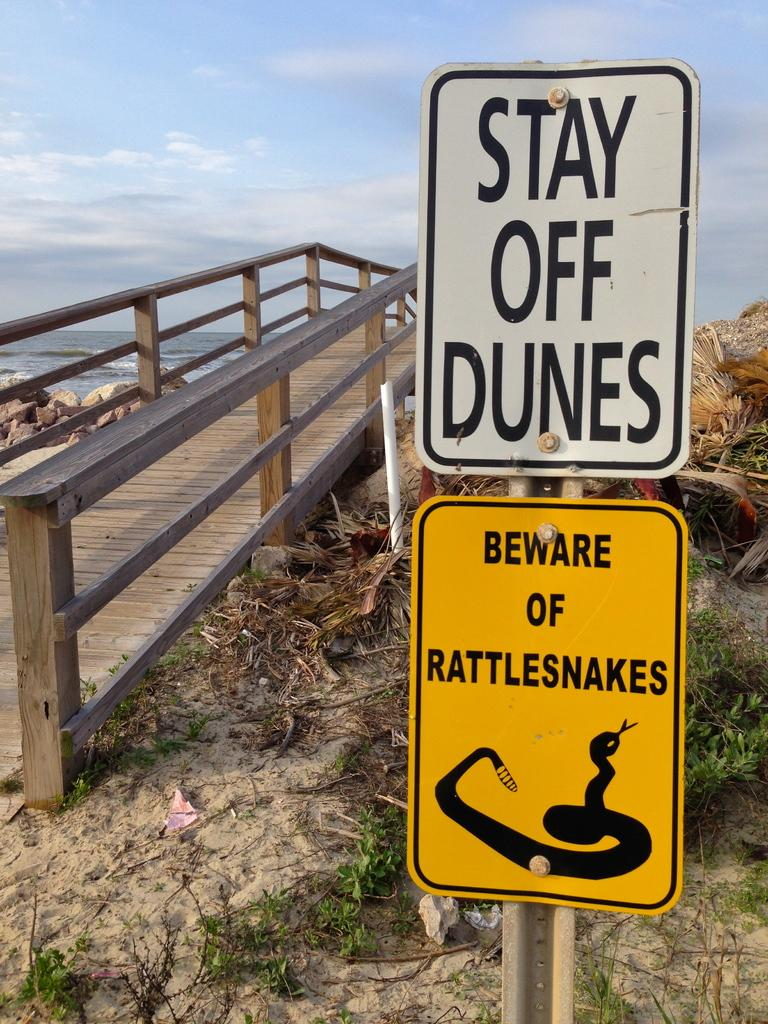Provide a one-sentence caption for the provided image. signs that warnsm of rattlesnakes on the beach. 